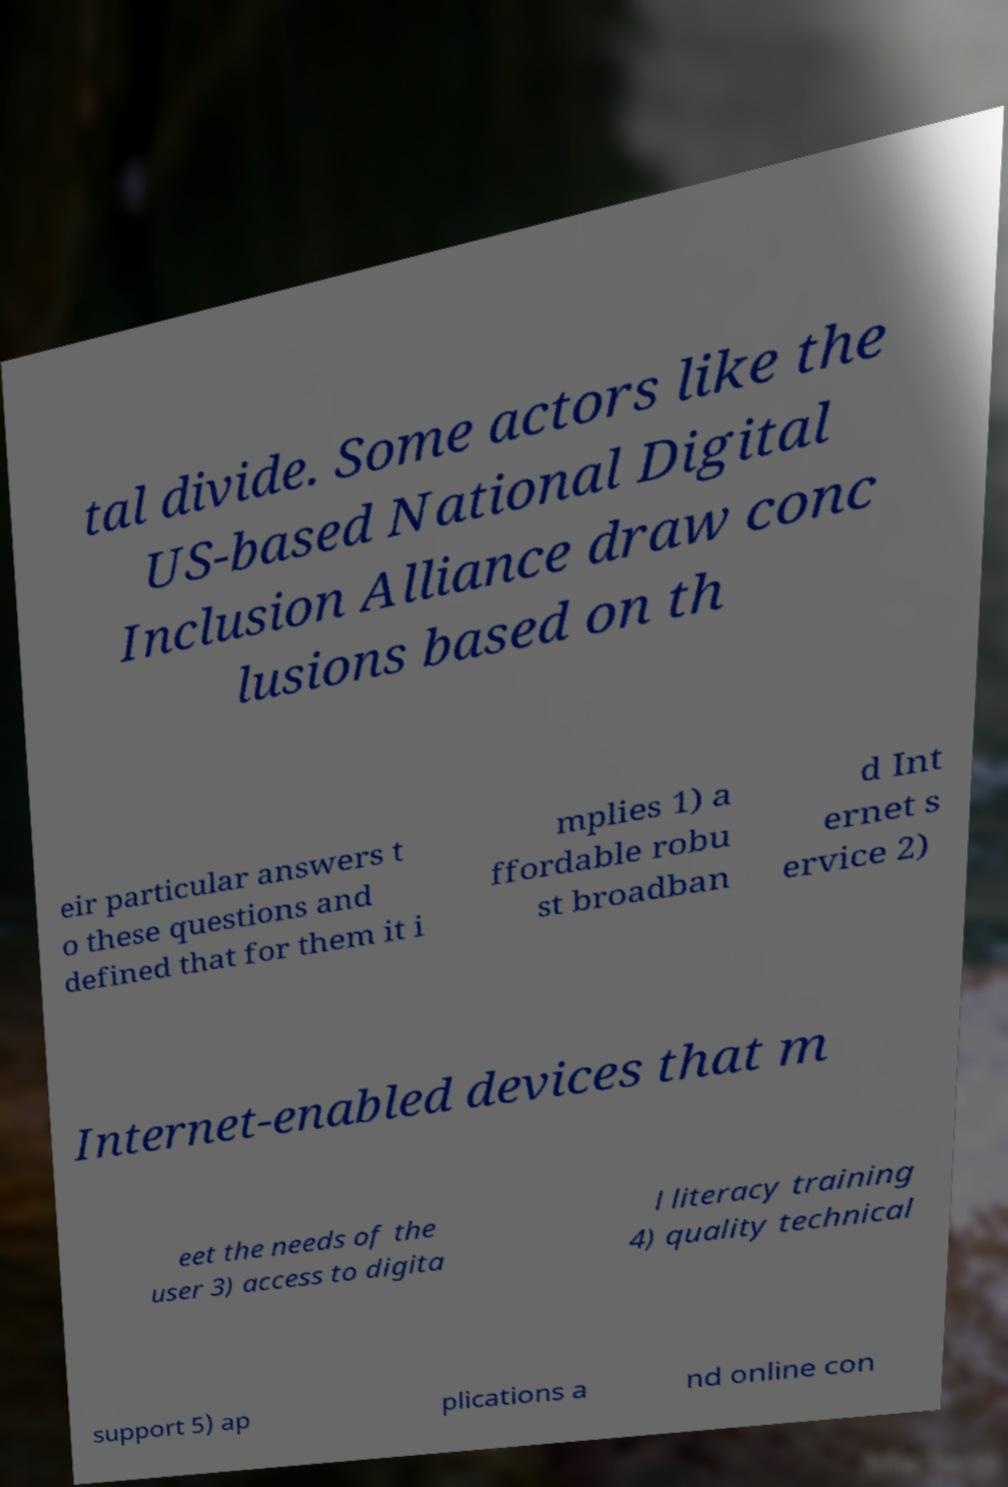Please read and relay the text visible in this image. What does it say? tal divide. Some actors like the US-based National Digital Inclusion Alliance draw conc lusions based on th eir particular answers t o these questions and defined that for them it i mplies 1) a ffordable robu st broadban d Int ernet s ervice 2) Internet-enabled devices that m eet the needs of the user 3) access to digita l literacy training 4) quality technical support 5) ap plications a nd online con 